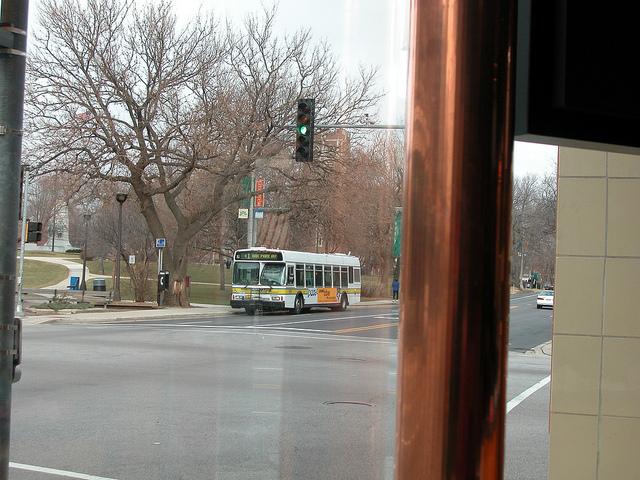How many buses are there?
Concise answer only. 1. What color is the traffic light?
Short answer required. Green. How many lamp posts are there?
Be succinct. 2. Is this a sunny day?
Answer briefly. No. 